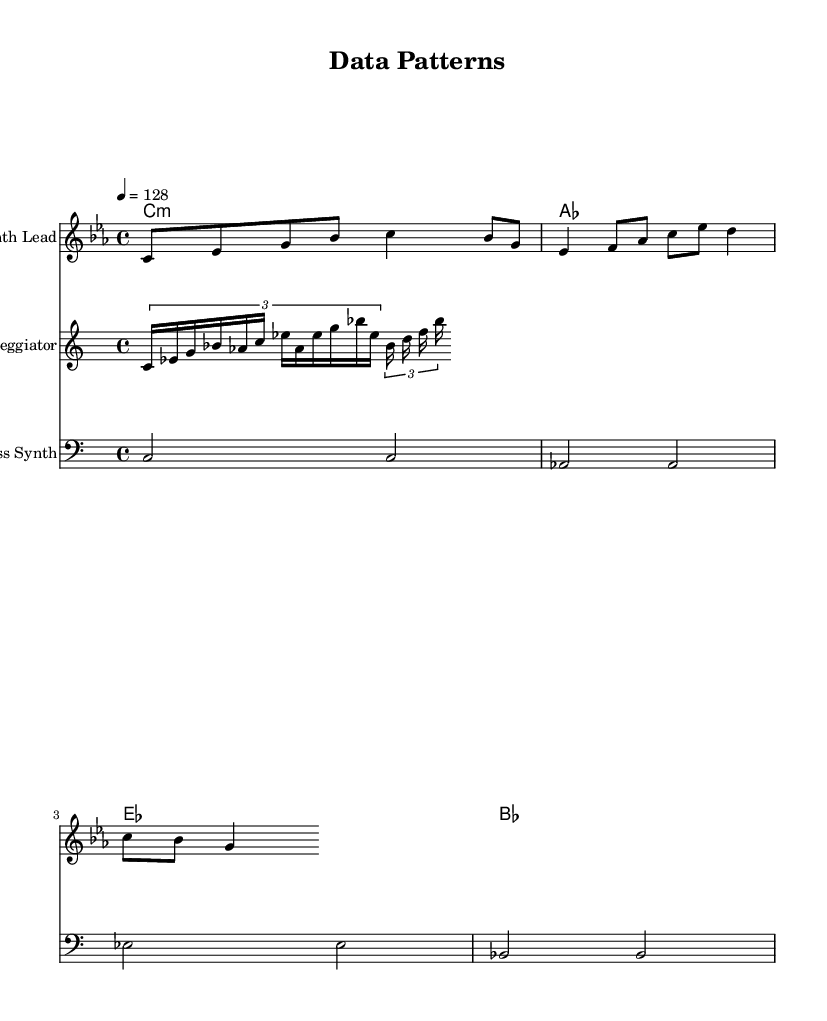What is the key signature of this music? The key signature is C minor, which contains three flats: B flat, E flat, and A flat. This is identified by the flat symbols placed at the beginning of the staff before the notes.
Answer: C minor What is the time signature of this piece? The time signature is 4/4, meaning there are four beats in each measure and a quarter note receives one beat. This is indicated at the beginning of the staff.
Answer: 4/4 What is the tempo marking given in the score? The tempo marking is 128 beats per minute, indicated by the number '128' following the word 'tempo' at the beginning of the score.
Answer: 128 How many measures are present in the melody? There are eight measures in the melody section. This is determined by counting the sets of vertical bar lines which indicate the end of each measure.
Answer: 8 What type of musical structure does the bass part exhibit? The bass part exhibits a repetitive structure with two notes being sustained over two measures, which is common in electronic music focusing on groove.
Answer: Repetitive Which instrument is indicated as having the melody? The melody is indicated to be played by the "Synth Lead," as stated at the beginning of the corresponding staff.
Answer: Synth Lead What type of musical effect is created by the arpeggiator? The arpeggiator creates a broken chord effect, where the notes of the chord are played in a sequence rather than simultaneously, adding texture to the track.
Answer: Broken chord 